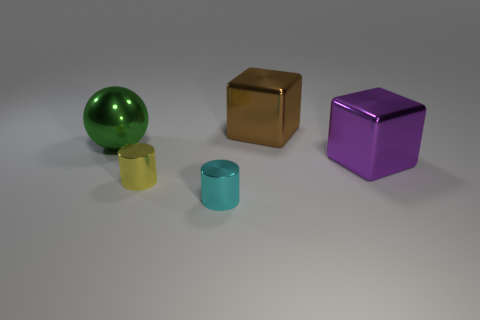Are there any purple shiny things that have the same size as the cyan metallic cylinder?
Your answer should be compact. No. What size is the metallic cylinder in front of the small yellow metal cylinder?
Offer a terse response. Small. The yellow shiny object is what size?
Ensure brevity in your answer.  Small. How many cubes are cyan metal things or tiny brown matte things?
Your answer should be very brief. 0. What size is the yellow thing that is the same material as the ball?
Your response must be concise. Small. Are there any yellow things right of the yellow metallic cylinder?
Keep it short and to the point. No. There is a purple metallic thing; does it have the same shape as the big shiny object that is behind the large green sphere?
Your answer should be compact. Yes. How many objects are large metallic objects that are behind the purple cube or large green metallic things?
Make the answer very short. 2. Is there any other thing that has the same material as the yellow cylinder?
Offer a terse response. Yes. What number of things are both in front of the big purple metal object and behind the purple thing?
Provide a succinct answer. 0. 